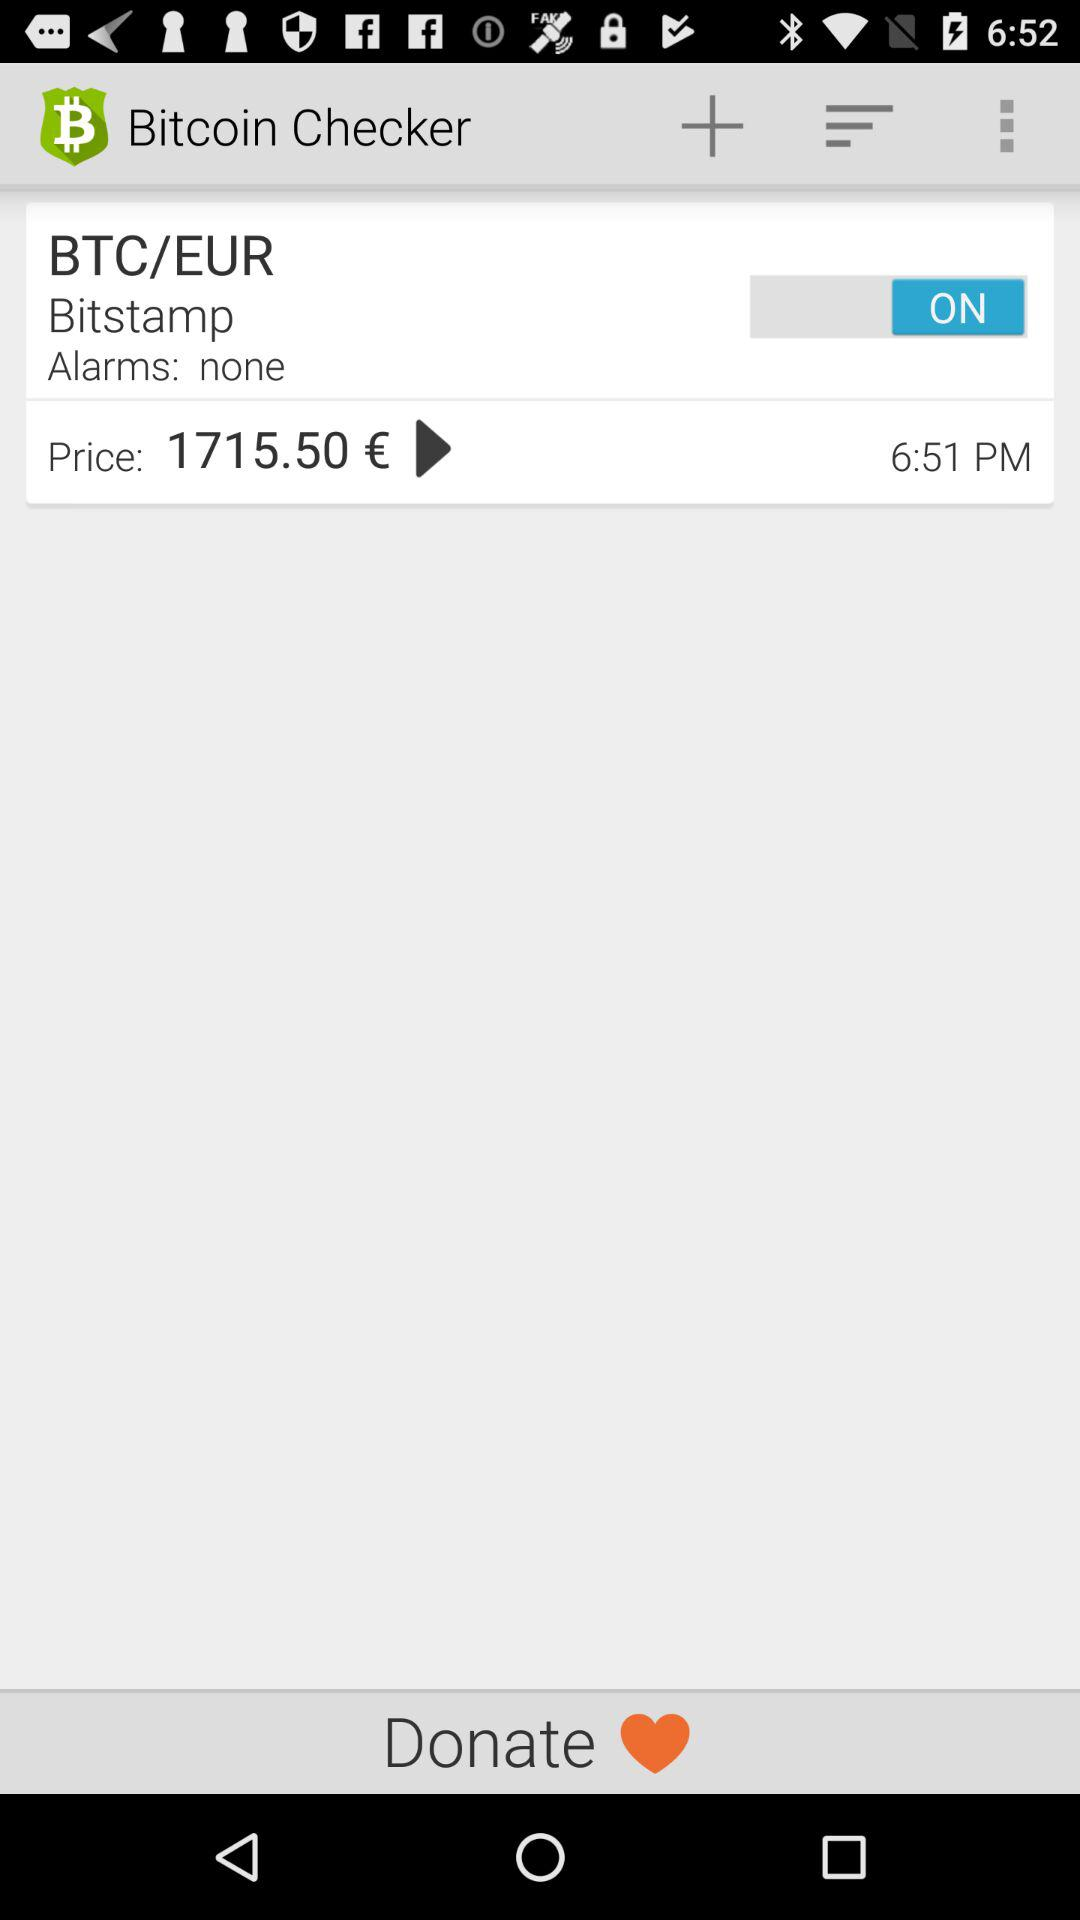How much is the price of Bitcoin in Euros?
Answer the question using a single word or phrase. 1715.50 € 